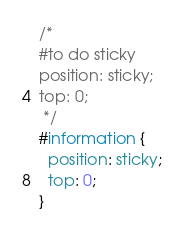Convert code to text. <code><loc_0><loc_0><loc_500><loc_500><_CSS_>/*
#to do sticky
position: sticky;
top: 0;
 */
#information {
  position: sticky;
  top: 0;
}
</code> 